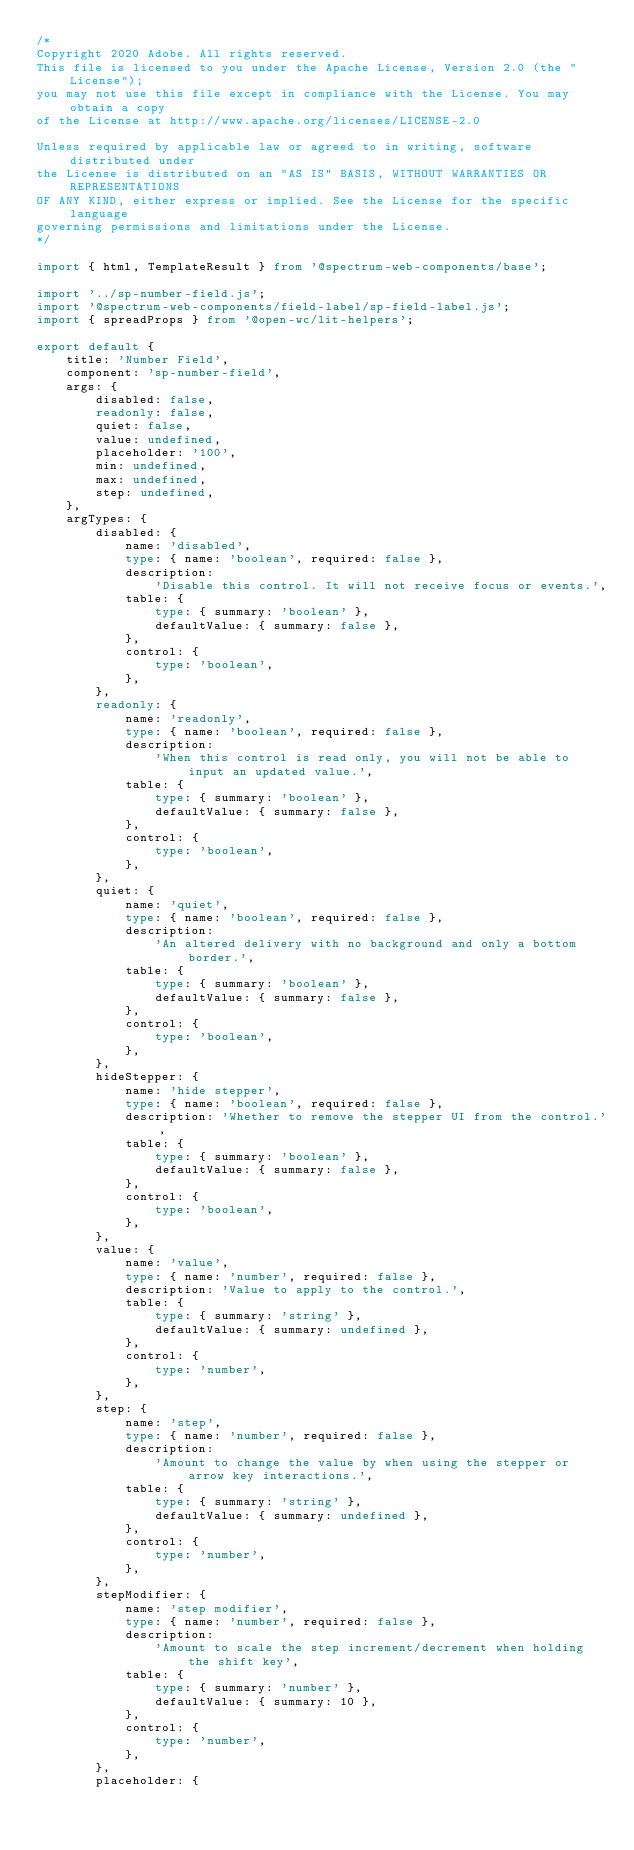Convert code to text. <code><loc_0><loc_0><loc_500><loc_500><_TypeScript_>/*
Copyright 2020 Adobe. All rights reserved.
This file is licensed to you under the Apache License, Version 2.0 (the "License");
you may not use this file except in compliance with the License. You may obtain a copy
of the License at http://www.apache.org/licenses/LICENSE-2.0

Unless required by applicable law or agreed to in writing, software distributed under
the License is distributed on an "AS IS" BASIS, WITHOUT WARRANTIES OR REPRESENTATIONS
OF ANY KIND, either express or implied. See the License for the specific language
governing permissions and limitations under the License.
*/

import { html, TemplateResult } from '@spectrum-web-components/base';

import '../sp-number-field.js';
import '@spectrum-web-components/field-label/sp-field-label.js';
import { spreadProps } from '@open-wc/lit-helpers';

export default {
    title: 'Number Field',
    component: 'sp-number-field',
    args: {
        disabled: false,
        readonly: false,
        quiet: false,
        value: undefined,
        placeholder: '100',
        min: undefined,
        max: undefined,
        step: undefined,
    },
    argTypes: {
        disabled: {
            name: 'disabled',
            type: { name: 'boolean', required: false },
            description:
                'Disable this control. It will not receive focus or events.',
            table: {
                type: { summary: 'boolean' },
                defaultValue: { summary: false },
            },
            control: {
                type: 'boolean',
            },
        },
        readonly: {
            name: 'readonly',
            type: { name: 'boolean', required: false },
            description:
                'When this control is read only, you will not be able to input an updated value.',
            table: {
                type: { summary: 'boolean' },
                defaultValue: { summary: false },
            },
            control: {
                type: 'boolean',
            },
        },
        quiet: {
            name: 'quiet',
            type: { name: 'boolean', required: false },
            description:
                'An altered delivery with no background and only a bottom border.',
            table: {
                type: { summary: 'boolean' },
                defaultValue: { summary: false },
            },
            control: {
                type: 'boolean',
            },
        },
        hideStepper: {
            name: 'hide stepper',
            type: { name: 'boolean', required: false },
            description: 'Whether to remove the stepper UI from the control.',
            table: {
                type: { summary: 'boolean' },
                defaultValue: { summary: false },
            },
            control: {
                type: 'boolean',
            },
        },
        value: {
            name: 'value',
            type: { name: 'number', required: false },
            description: 'Value to apply to the control.',
            table: {
                type: { summary: 'string' },
                defaultValue: { summary: undefined },
            },
            control: {
                type: 'number',
            },
        },
        step: {
            name: 'step',
            type: { name: 'number', required: false },
            description:
                'Amount to change the value by when using the stepper or arrow key interactions.',
            table: {
                type: { summary: 'string' },
                defaultValue: { summary: undefined },
            },
            control: {
                type: 'number',
            },
        },
        stepModifier: {
            name: 'step modifier',
            type: { name: 'number', required: false },
            description:
                'Amount to scale the step increment/decrement when holding the shift key',
            table: {
                type: { summary: 'number' },
                defaultValue: { summary: 10 },
            },
            control: {
                type: 'number',
            },
        },
        placeholder: {</code> 